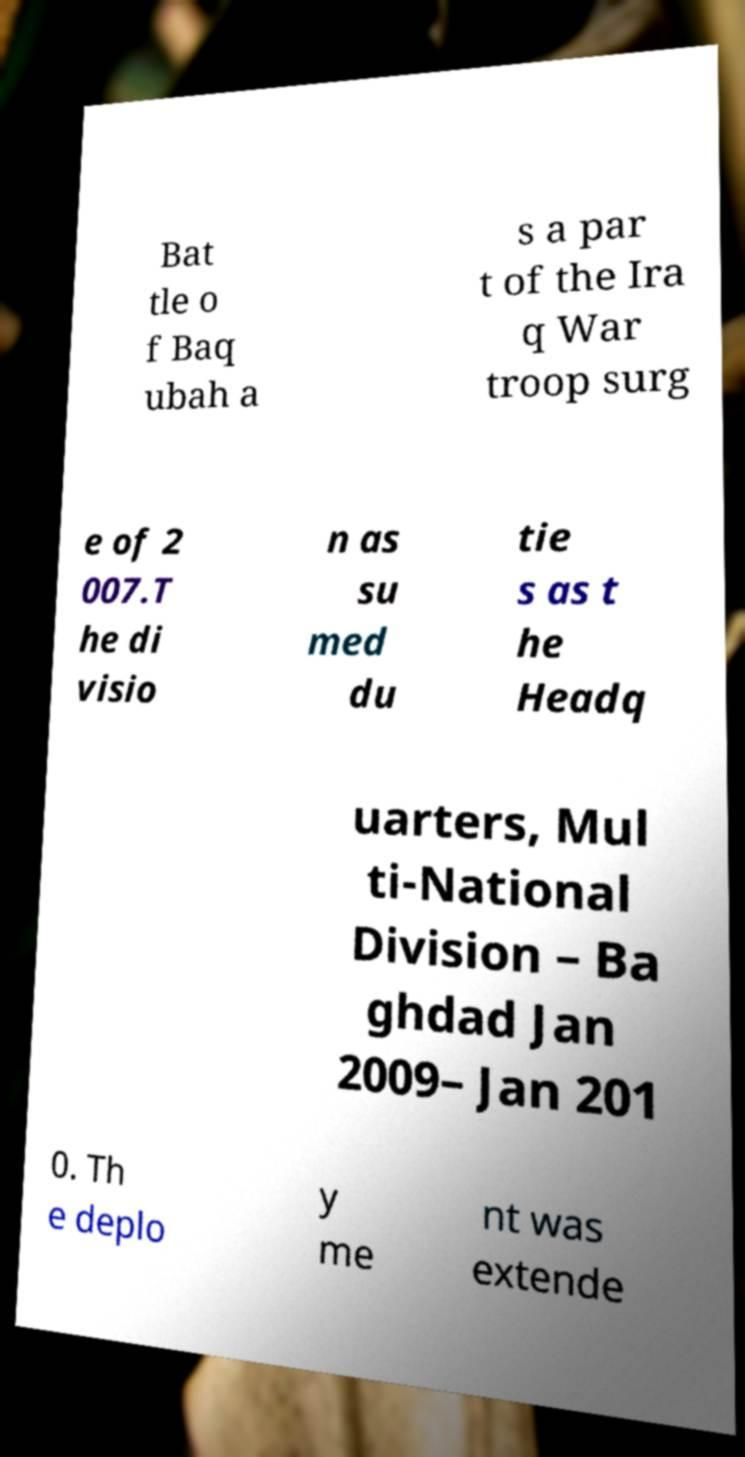There's text embedded in this image that I need extracted. Can you transcribe it verbatim? Bat tle o f Baq ubah a s a par t of the Ira q War troop surg e of 2 007.T he di visio n as su med du tie s as t he Headq uarters, Mul ti-National Division – Ba ghdad Jan 2009– Jan 201 0. Th e deplo y me nt was extende 